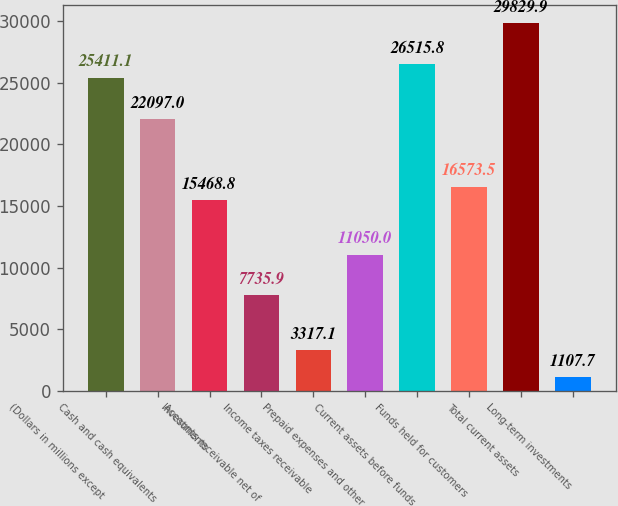Convert chart to OTSL. <chart><loc_0><loc_0><loc_500><loc_500><bar_chart><fcel>(Dollars in millions except<fcel>Cash and cash equivalents<fcel>Investments<fcel>Accounts receivable net of<fcel>Income taxes receivable<fcel>Prepaid expenses and other<fcel>Current assets before funds<fcel>Funds held for customers<fcel>Total current assets<fcel>Long-term investments<nl><fcel>25411.1<fcel>22097<fcel>15468.8<fcel>7735.9<fcel>3317.1<fcel>11050<fcel>26515.8<fcel>16573.5<fcel>29829.9<fcel>1107.7<nl></chart> 